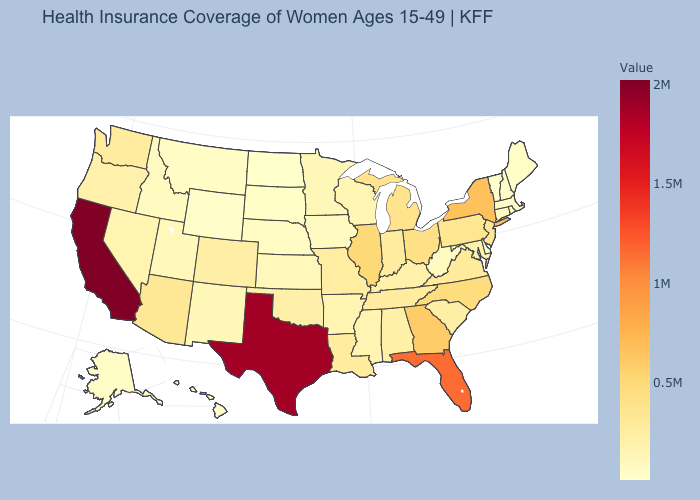Among the states that border Virginia , does West Virginia have the lowest value?
Answer briefly. Yes. Among the states that border Minnesota , which have the highest value?
Concise answer only. Wisconsin. Which states have the highest value in the USA?
Answer briefly. California. Does Vermont have the lowest value in the USA?
Quick response, please. Yes. Among the states that border Virginia , which have the lowest value?
Answer briefly. West Virginia. Which states have the highest value in the USA?
Short answer required. California. 